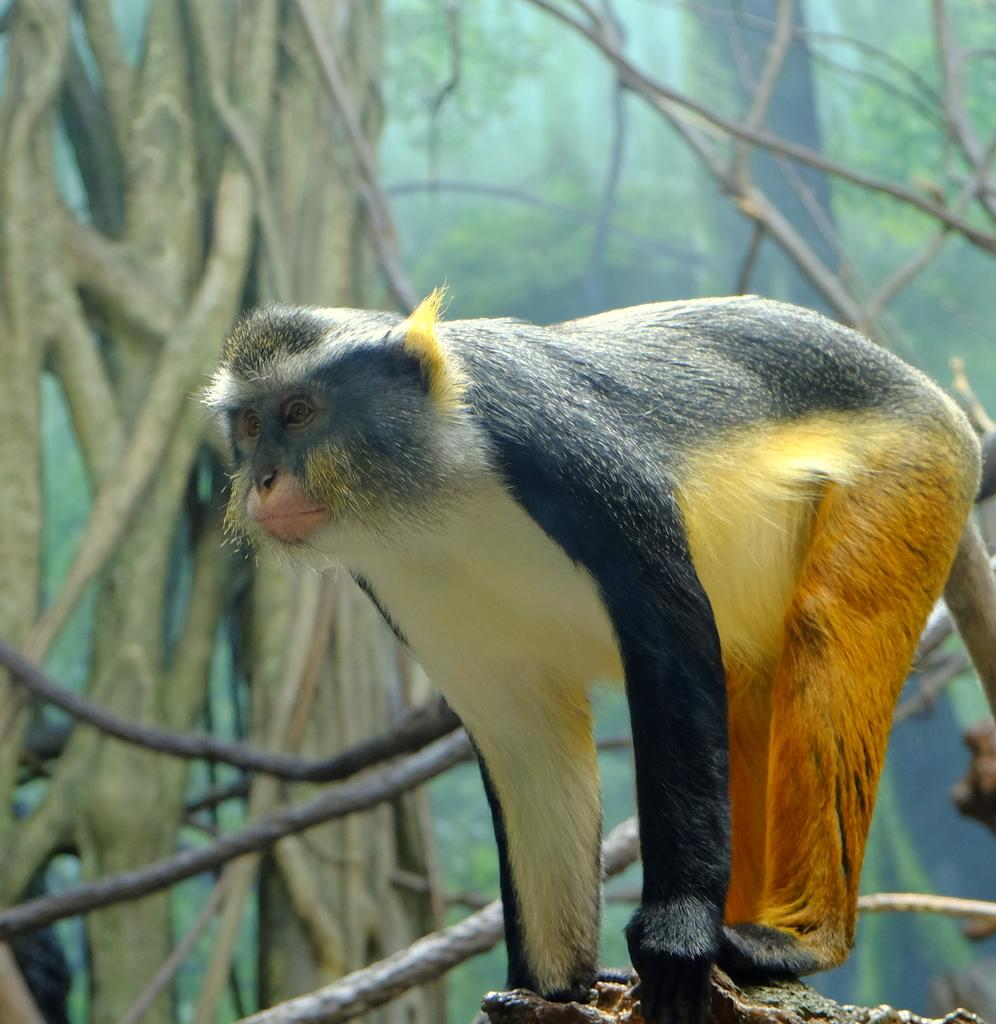What animal is in the picture? There is a monkey in the picture. What colors can be seen in the monkey's fur? The monkey has black, white, yellow, and orange fur. What is the monkey standing on in the picture? The monkey is standing on a rock. What can be seen in the background of the picture? There are trees in the background of the picture. What type of education does the monkey have in the picture? There is no indication of the monkey's education in the picture. What part of the monkey's body is missing in the picture? There is no part of the monkey's body missing in the picture; it appears to be complete. 